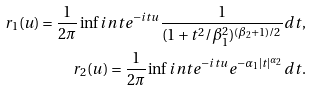Convert formula to latex. <formula><loc_0><loc_0><loc_500><loc_500>r _ { 1 } ( u ) = \frac { 1 } { 2 \pi } \inf i n t e ^ { - i t u } \frac { 1 } { ( 1 + t ^ { 2 } / \beta _ { 1 } ^ { 2 } ) ^ { ( \beta _ { 2 } + 1 ) / 2 } } d t , \\ r _ { 2 } ( u ) = \frac { 1 } { 2 \pi } \inf i n t e ^ { - i t u } e ^ { - \alpha _ { 1 } | t | ^ { \alpha _ { 2 } } } d t .</formula> 